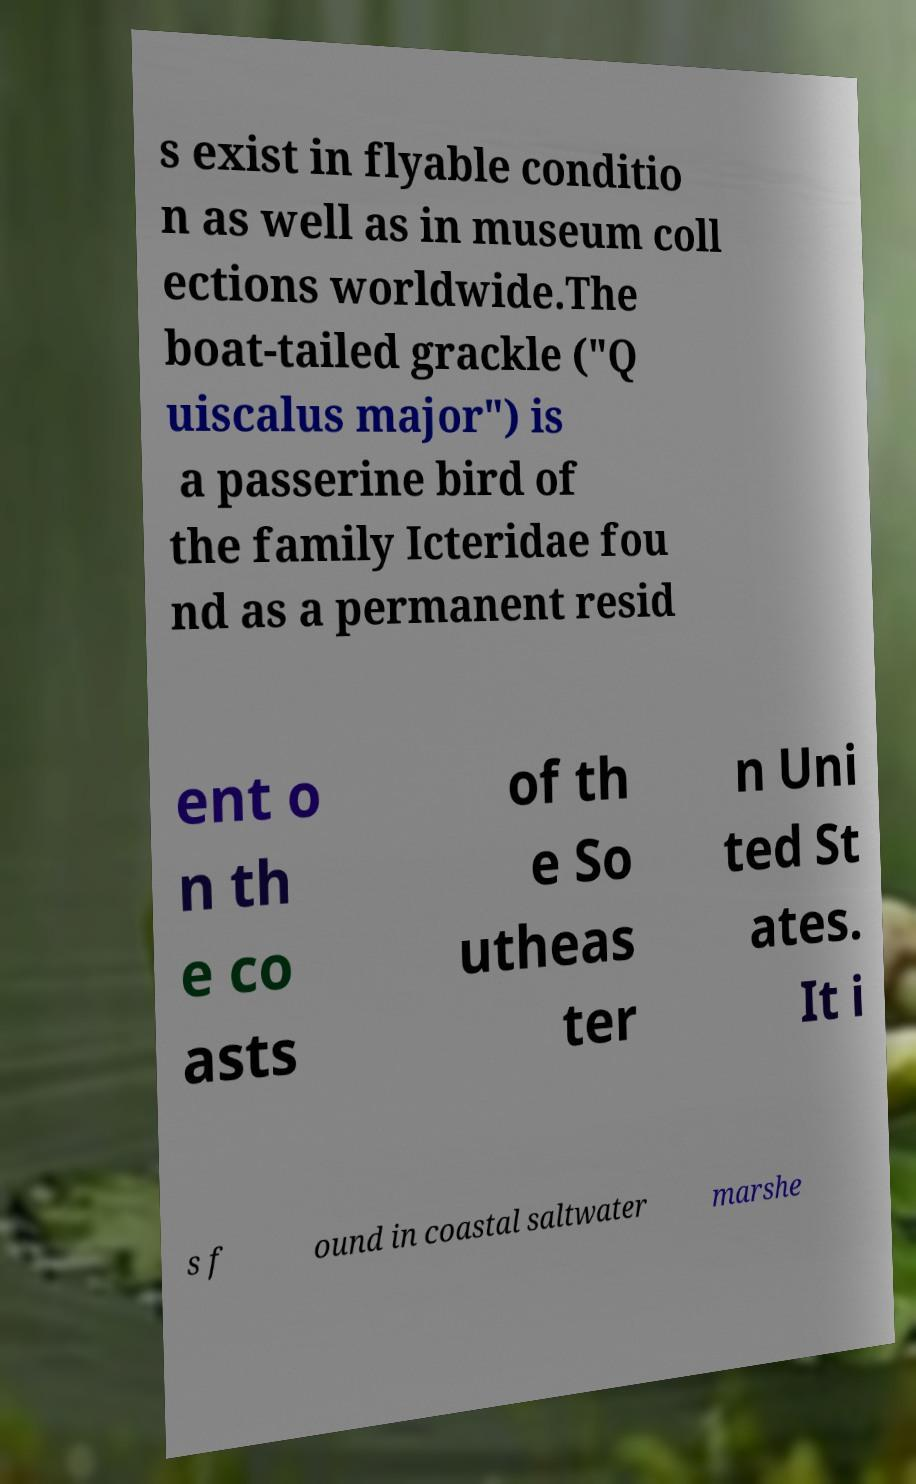Please read and relay the text visible in this image. What does it say? s exist in flyable conditio n as well as in museum coll ections worldwide.The boat-tailed grackle ("Q uiscalus major") is a passerine bird of the family Icteridae fou nd as a permanent resid ent o n th e co asts of th e So utheas ter n Uni ted St ates. It i s f ound in coastal saltwater marshe 